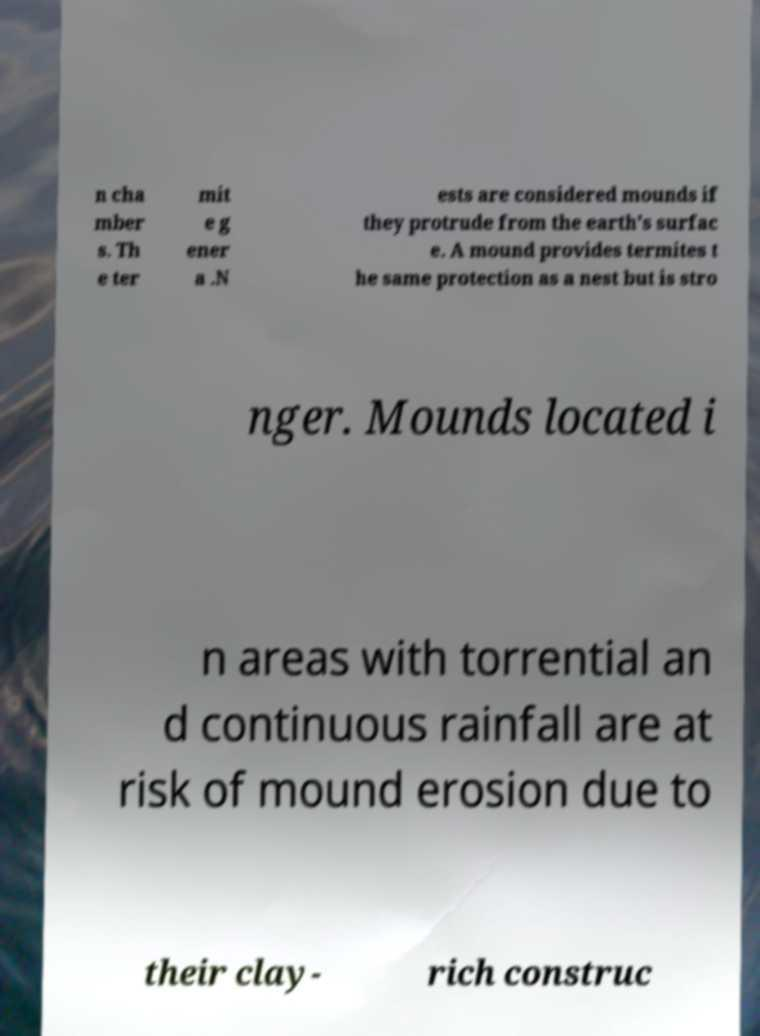Please read and relay the text visible in this image. What does it say? n cha mber s. Th e ter mit e g ener a .N ests are considered mounds if they protrude from the earth's surfac e. A mound provides termites t he same protection as a nest but is stro nger. Mounds located i n areas with torrential an d continuous rainfall are at risk of mound erosion due to their clay- rich construc 